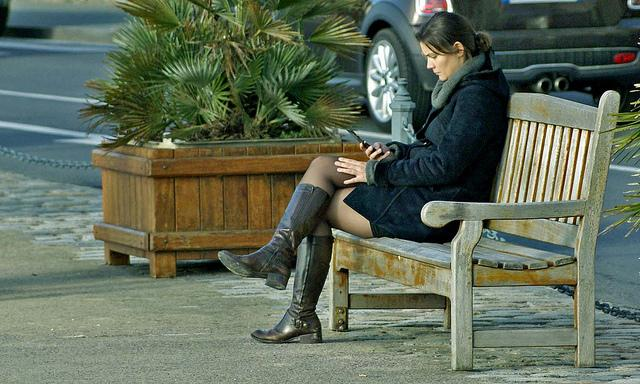What is she doing?

Choices:
A) talkin
B) checking facebook
C) ordering lunch
D) texting friend texting friend 